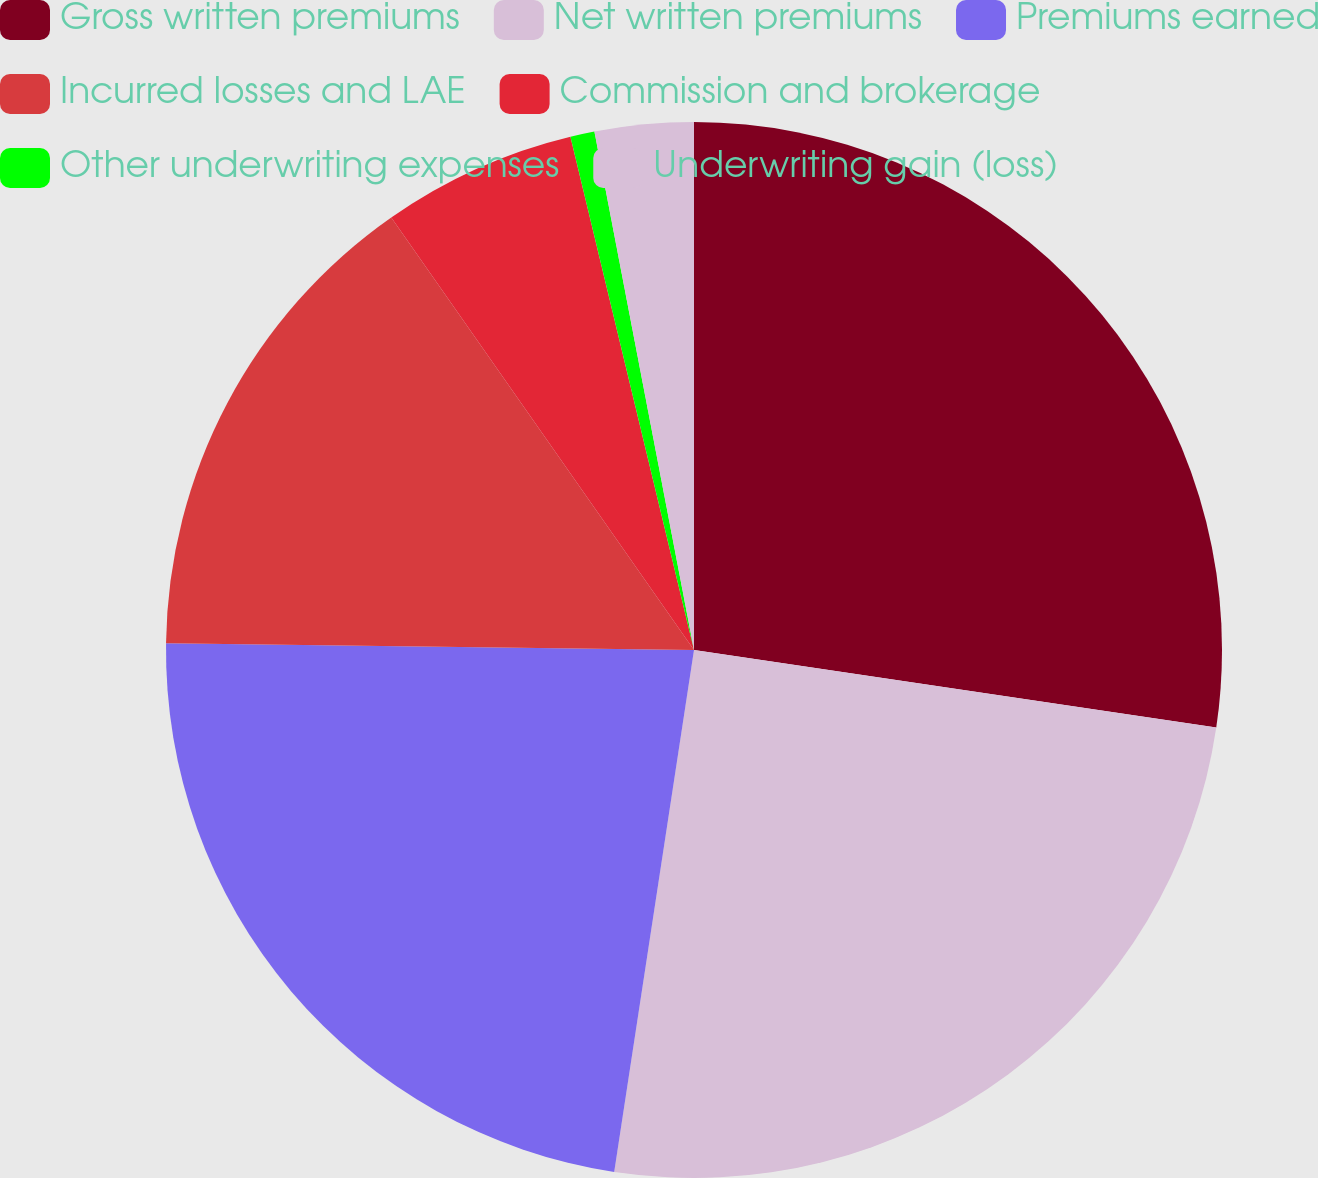Convert chart. <chart><loc_0><loc_0><loc_500><loc_500><pie_chart><fcel>Gross written premiums<fcel>Net written premiums<fcel>Premiums earned<fcel>Incurred losses and LAE<fcel>Commission and brokerage<fcel>Other underwriting expenses<fcel>Underwriting gain (loss)<nl><fcel>27.35%<fcel>25.07%<fcel>22.79%<fcel>15.08%<fcel>5.96%<fcel>0.74%<fcel>3.02%<nl></chart> 